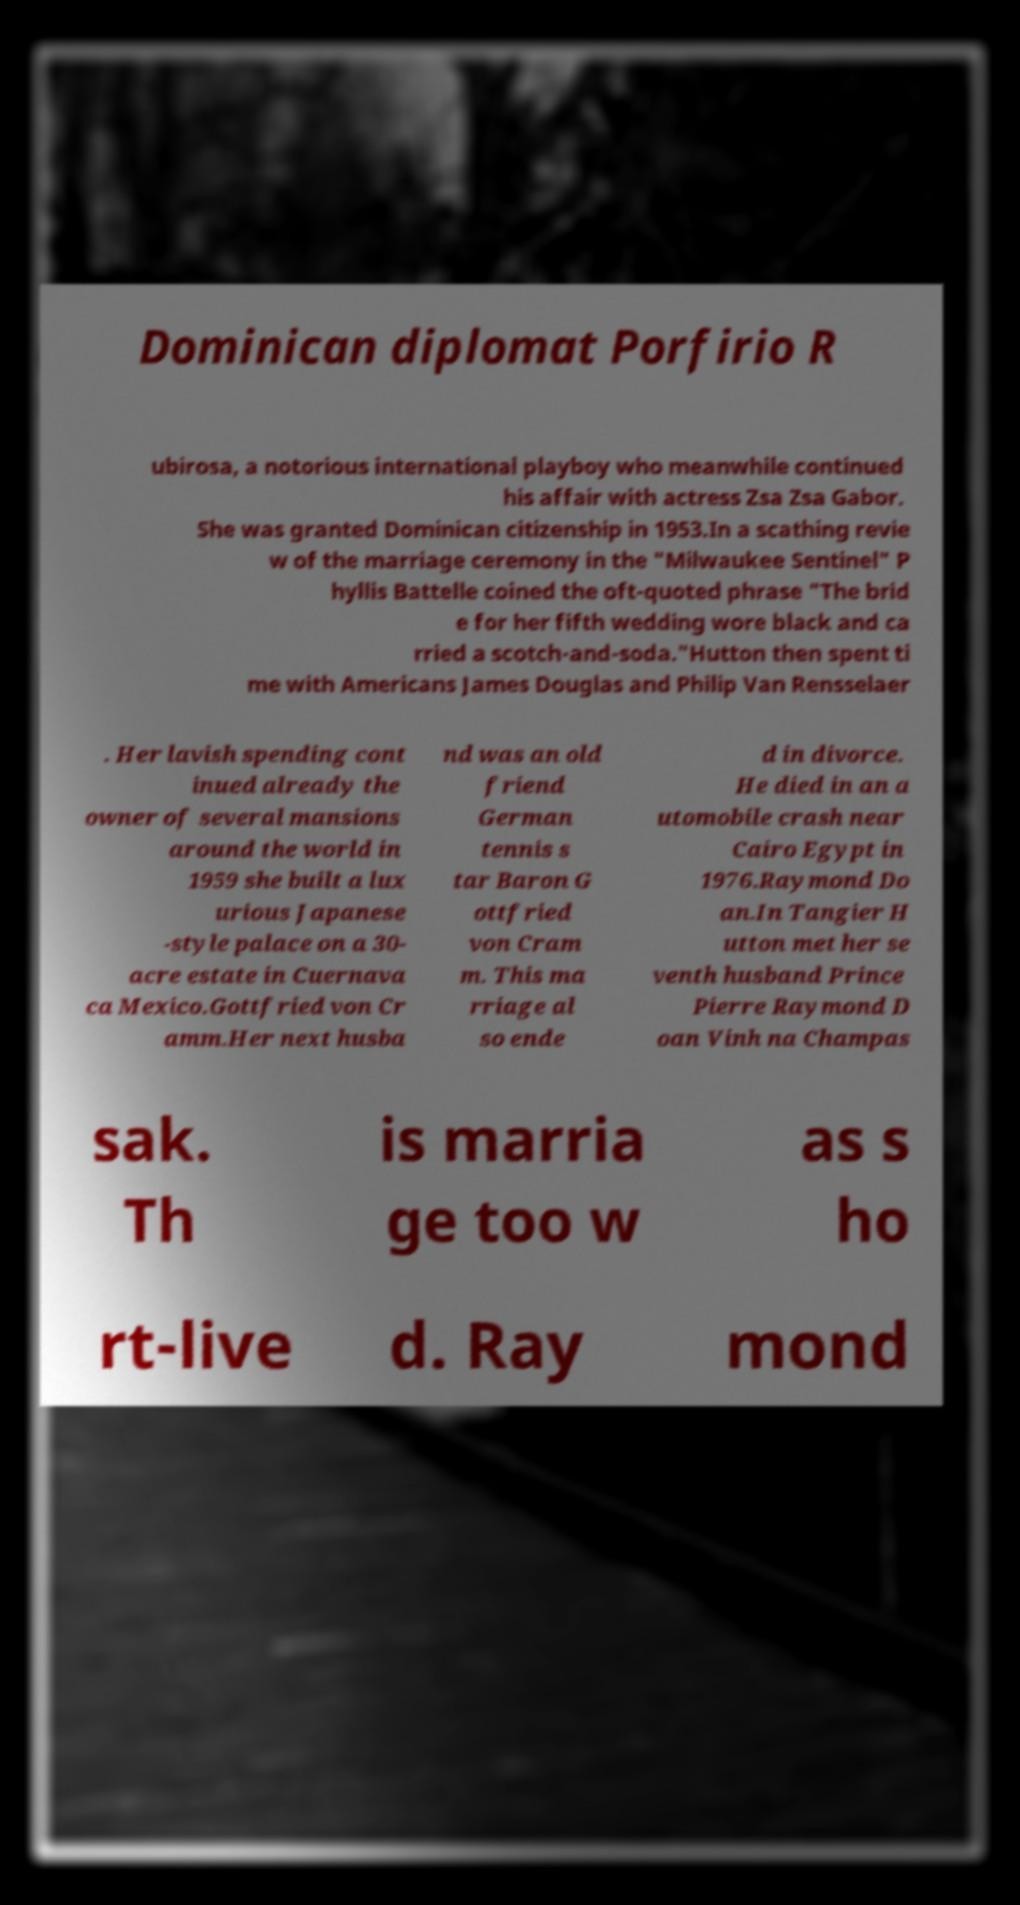What messages or text are displayed in this image? I need them in a readable, typed format. Dominican diplomat Porfirio R ubirosa, a notorious international playboy who meanwhile continued his affair with actress Zsa Zsa Gabor. She was granted Dominican citizenship in 1953.In a scathing revie w of the marriage ceremony in the "Milwaukee Sentinel" P hyllis Battelle coined the oft-quoted phrase "The brid e for her fifth wedding wore black and ca rried a scotch-and-soda."Hutton then spent ti me with Americans James Douglas and Philip Van Rensselaer . Her lavish spending cont inued already the owner of several mansions around the world in 1959 she built a lux urious Japanese -style palace on a 30- acre estate in Cuernava ca Mexico.Gottfried von Cr amm.Her next husba nd was an old friend German tennis s tar Baron G ottfried von Cram m. This ma rriage al so ende d in divorce. He died in an a utomobile crash near Cairo Egypt in 1976.Raymond Do an.In Tangier H utton met her se venth husband Prince Pierre Raymond D oan Vinh na Champas sak. Th is marria ge too w as s ho rt-live d. Ray mond 